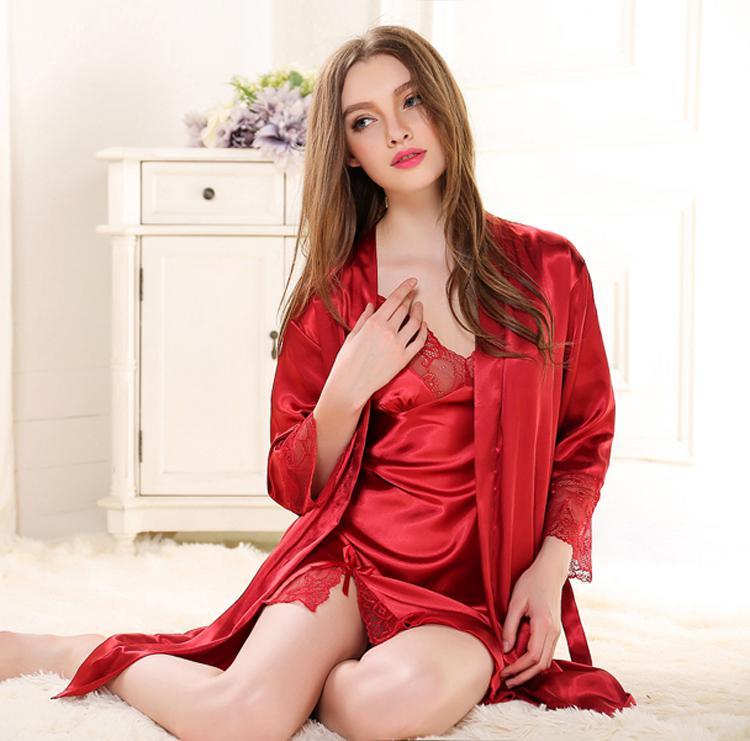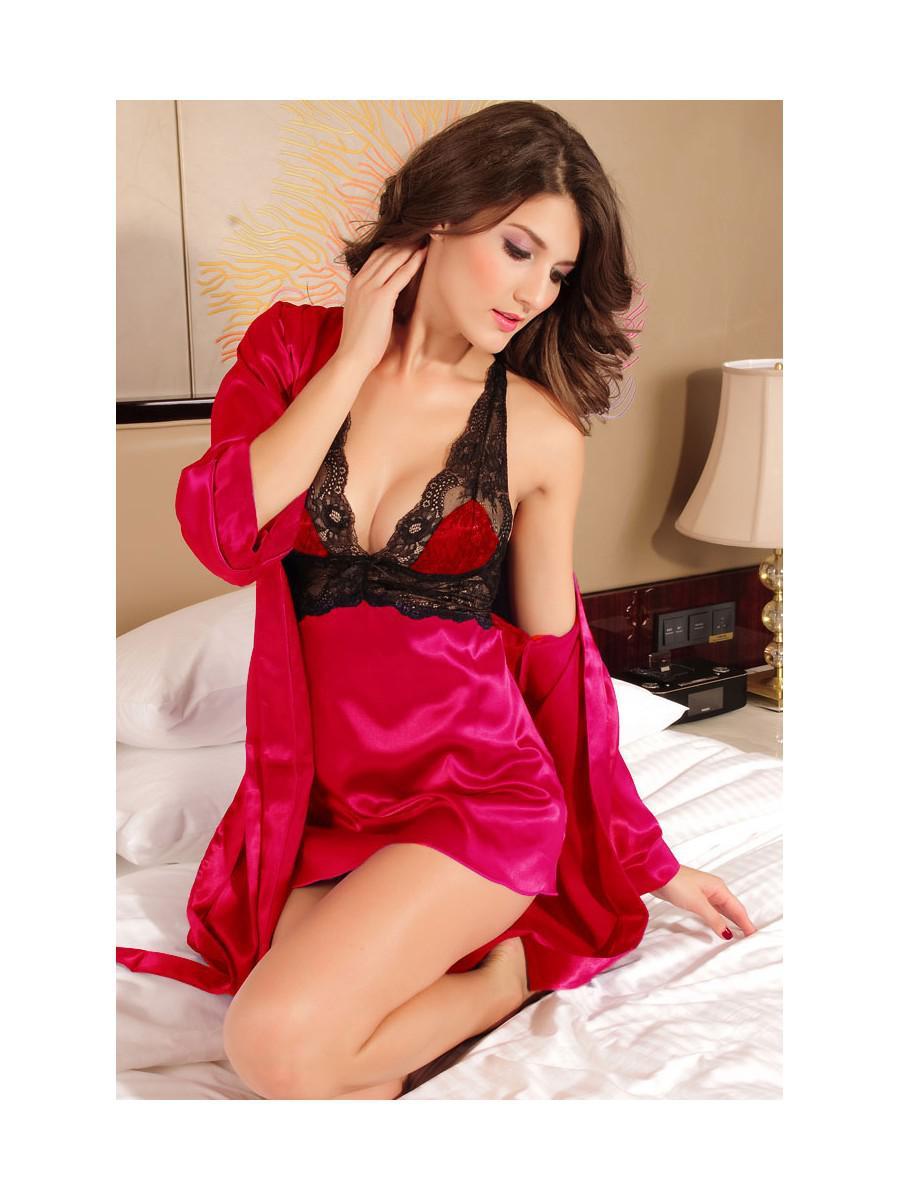The first image is the image on the left, the second image is the image on the right. For the images displayed, is the sentence "At least one image shows a woman standing." factually correct? Answer yes or no. No. The first image is the image on the left, the second image is the image on the right. Evaluate the accuracy of this statement regarding the images: "The image on the right has a model standing on her feet wearing lingerie.". Is it true? Answer yes or no. No. 